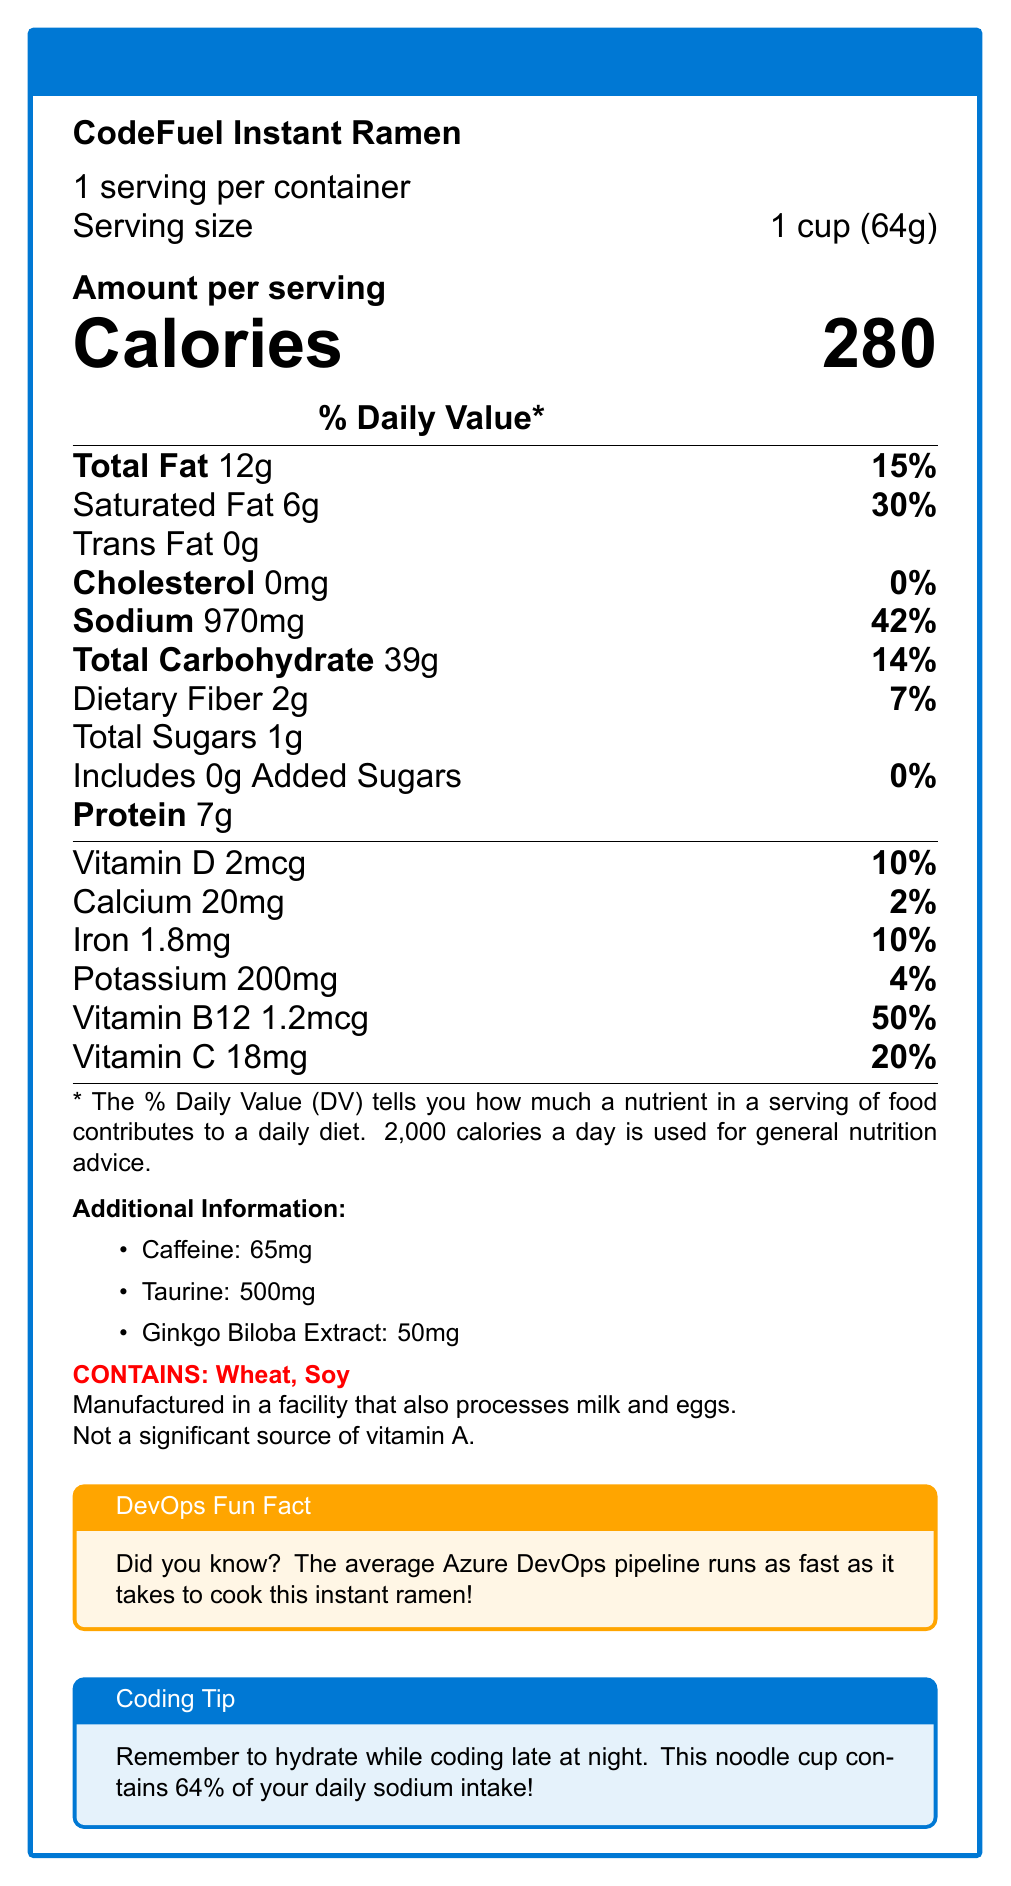what is the serving size for CodeFuel Instant Ramen? The document explicitly states that the serving size is "1 cup (64g)".
Answer: 1 cup (64g) how many calories are in one serving of CodeFuel Instant Ramen? The document lists that there are 280 calories per serving.
Answer: 280 calories what percentage of the daily value of saturated fat does one serving contain? Under the "Saturated Fat" section, it states that one serving contains 6g, which is 30% of the daily value.
Answer: 30% how much sodium is in one serving? The sodium content is listed as "Sodium 970mg".
Answer: 970 mg how much protein is in CodeFuel Instant Ramen? The document lists "Protein 7g" under the nutritional information.
Answer: 7g which vitamins are specifically mentioned in the nutrition facts? A. Vitamin A, Vitamin B6, Vitamin B12 B. Vitamin D, Vitamin C, Vitamin B12 C. Vitamin E, Vitamin K, Vitamin D D. Vitamin A, Vitamin C, Vitamin E The document lists Vitamin D, Vitamin C, and Vitamin B12 with their amounts and daily values.
Answer: B how much taurine is included in the product? A. 150 mg B. 300 mg C. 500 mg D. 700 mg The "Additional Information" section lists Taurine 500mg.
Answer: C. 500 mg does this product contain any cholesterol? The document states "Cholesterol 0mg" which means it contains no cholesterol.
Answer: No is this product a significant source of vitamin A? The document explicitly mentions "Not a significant source of vitamin A."
Answer: No can you determine the exact caffeine content per serving from this document? The caffeine content is specifically listed in the "Additional Information" section as 65mg.
Answer: Yes, 65mg summarize the main nutritional aspects of CodeFuel Instant Ramen. This summary captures all the significant nutritional details including macronutrients, vitamins, added components, and allergen information.
Answer: CodeFuel Instant Ramen is an instant noodle cup containing 280 calories per serving. It has 12g of total fat, 6g of saturated fat, no trans fat, and no cholesterol. The sodium content is high at 970mg, which is 42% of the daily value. It also contains 39g of total carbohydrates, 2g of dietary fiber, and 7g of protein. The product is fortified with vitamins like Vitamin D, Vitamin B12, and Vitamin C, as well as additional components such as caffeine, taurine, and ginkgo biloba extract. It is important to note that it contains wheat and soy and is manufactured in a facility processing milk and eggs. what are the ingredients listed on the label? The document does not provide the ingredients list, only the nutritional content and additional information.
Answer: Not enough information what fun fact about Azure DevOps is mentioned? The document includes a "DevOps Fun Fact" that states this information.
Answer: The average Azure DevOps pipeline runs as fast as it takes to cook this instant ramen! what coding tip is provided in the document? The document includes a "Coding Tip" that suggests hydrating while coding late at night and points out the high sodium content in the cup.
Answer: Remember to hydrate while coding late at night. This noodle cup contains 64% of your daily sodium intake! 